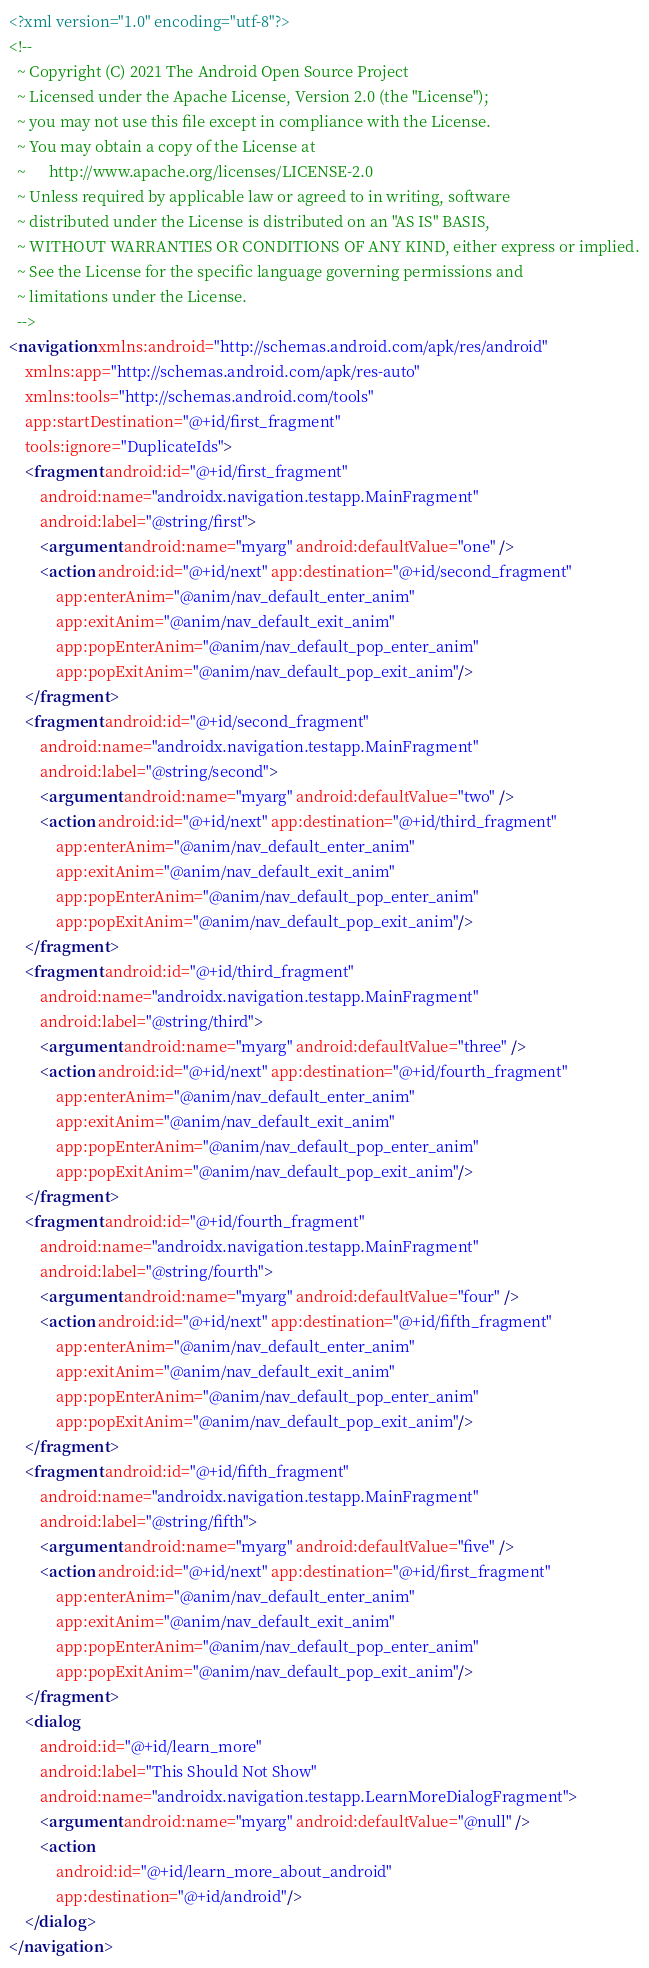<code> <loc_0><loc_0><loc_500><loc_500><_XML_><?xml version="1.0" encoding="utf-8"?>
<!--
  ~ Copyright (C) 2021 The Android Open Source Project
  ~ Licensed under the Apache License, Version 2.0 (the "License");
  ~ you may not use this file except in compliance with the License.
  ~ You may obtain a copy of the License at
  ~      http://www.apache.org/licenses/LICENSE-2.0
  ~ Unless required by applicable law or agreed to in writing, software
  ~ distributed under the License is distributed on an "AS IS" BASIS,
  ~ WITHOUT WARRANTIES OR CONDITIONS OF ANY KIND, either express or implied.
  ~ See the License for the specific language governing permissions and
  ~ limitations under the License.
  -->
<navigation xmlns:android="http://schemas.android.com/apk/res/android"
    xmlns:app="http://schemas.android.com/apk/res-auto"
    xmlns:tools="http://schemas.android.com/tools"
    app:startDestination="@+id/first_fragment"
    tools:ignore="DuplicateIds">
    <fragment android:id="@+id/first_fragment"
        android:name="androidx.navigation.testapp.MainFragment"
        android:label="@string/first">
        <argument android:name="myarg" android:defaultValue="one" />
        <action android:id="@+id/next" app:destination="@+id/second_fragment"
            app:enterAnim="@anim/nav_default_enter_anim"
            app:exitAnim="@anim/nav_default_exit_anim"
            app:popEnterAnim="@anim/nav_default_pop_enter_anim"
            app:popExitAnim="@anim/nav_default_pop_exit_anim"/>
    </fragment>
    <fragment android:id="@+id/second_fragment"
        android:name="androidx.navigation.testapp.MainFragment"
        android:label="@string/second">
        <argument android:name="myarg" android:defaultValue="two" />
        <action android:id="@+id/next" app:destination="@+id/third_fragment"
            app:enterAnim="@anim/nav_default_enter_anim"
            app:exitAnim="@anim/nav_default_exit_anim"
            app:popEnterAnim="@anim/nav_default_pop_enter_anim"
            app:popExitAnim="@anim/nav_default_pop_exit_anim"/>
    </fragment>
    <fragment android:id="@+id/third_fragment"
        android:name="androidx.navigation.testapp.MainFragment"
        android:label="@string/third">
        <argument android:name="myarg" android:defaultValue="three" />
        <action android:id="@+id/next" app:destination="@+id/fourth_fragment"
            app:enterAnim="@anim/nav_default_enter_anim"
            app:exitAnim="@anim/nav_default_exit_anim"
            app:popEnterAnim="@anim/nav_default_pop_enter_anim"
            app:popExitAnim="@anim/nav_default_pop_exit_anim"/>
    </fragment>
    <fragment android:id="@+id/fourth_fragment"
        android:name="androidx.navigation.testapp.MainFragment"
        android:label="@string/fourth">
        <argument android:name="myarg" android:defaultValue="four" />
        <action android:id="@+id/next" app:destination="@+id/fifth_fragment"
            app:enterAnim="@anim/nav_default_enter_anim"
            app:exitAnim="@anim/nav_default_exit_anim"
            app:popEnterAnim="@anim/nav_default_pop_enter_anim"
            app:popExitAnim="@anim/nav_default_pop_exit_anim"/>
    </fragment>
    <fragment android:id="@+id/fifth_fragment"
        android:name="androidx.navigation.testapp.MainFragment"
        android:label="@string/fifth">
        <argument android:name="myarg" android:defaultValue="five" />
        <action android:id="@+id/next" app:destination="@+id/first_fragment"
            app:enterAnim="@anim/nav_default_enter_anim"
            app:exitAnim="@anim/nav_default_exit_anim"
            app:popEnterAnim="@anim/nav_default_pop_enter_anim"
            app:popExitAnim="@anim/nav_default_pop_exit_anim"/>
    </fragment>
    <dialog
        android:id="@+id/learn_more"
        android:label="This Should Not Show"
        android:name="androidx.navigation.testapp.LearnMoreDialogFragment">
        <argument android:name="myarg" android:defaultValue="@null" />
        <action
            android:id="@+id/learn_more_about_android"
            app:destination="@+id/android"/>
    </dialog>
</navigation></code> 